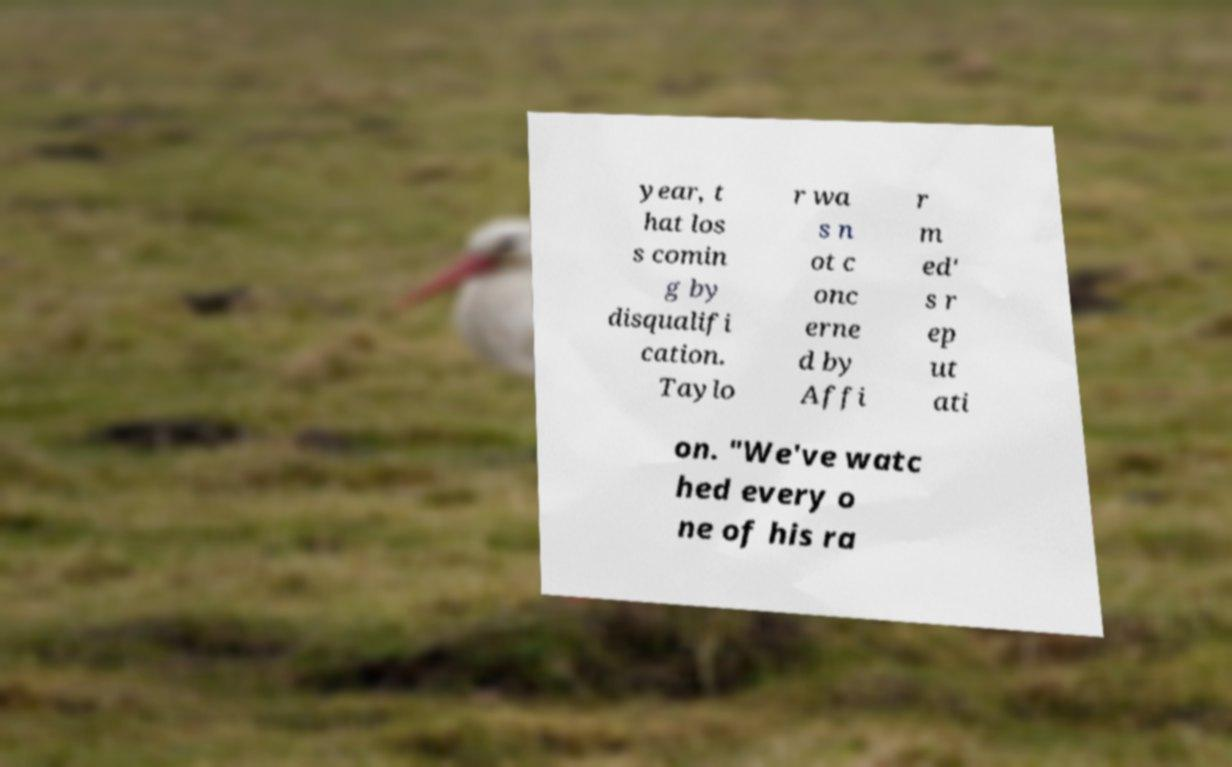Can you read and provide the text displayed in the image?This photo seems to have some interesting text. Can you extract and type it out for me? year, t hat los s comin g by disqualifi cation. Taylo r wa s n ot c onc erne d by Affi r m ed' s r ep ut ati on. "We've watc hed every o ne of his ra 